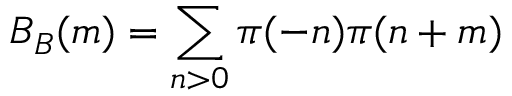<formula> <loc_0><loc_0><loc_500><loc_500>B _ { B } ( m ) = \sum _ { n > 0 } \pi ( - n ) \pi ( n + m )</formula> 